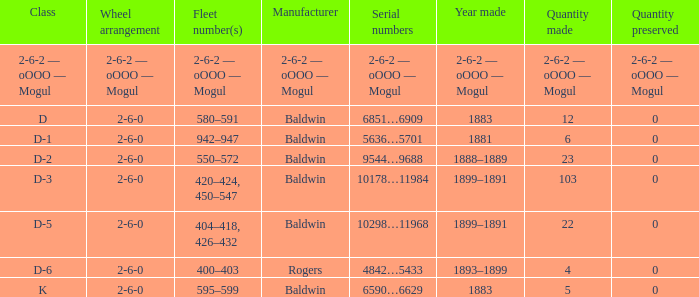What is the quantity made when the class is d-2? 23.0. 